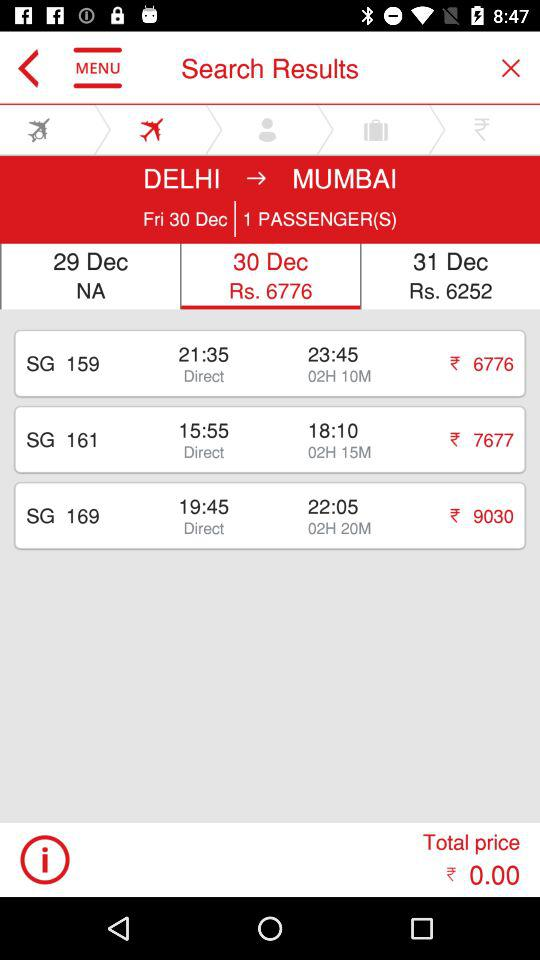What is the total price? The total price is ₹0. 